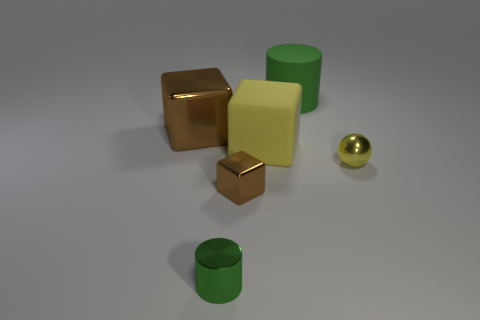Add 2 large cyan rubber things. How many objects exist? 8 Subtract all brown metal cubes. How many cubes are left? 1 Subtract all cylinders. How many objects are left? 4 Subtract all red cubes. Subtract all green spheres. How many cubes are left? 3 Subtract all red balls. How many brown cubes are left? 2 Subtract all brown cubes. Subtract all large yellow cubes. How many objects are left? 3 Add 3 small brown metal cubes. How many small brown metal cubes are left? 4 Add 4 small things. How many small things exist? 7 Subtract all brown cubes. How many cubes are left? 1 Subtract 0 blue cylinders. How many objects are left? 6 